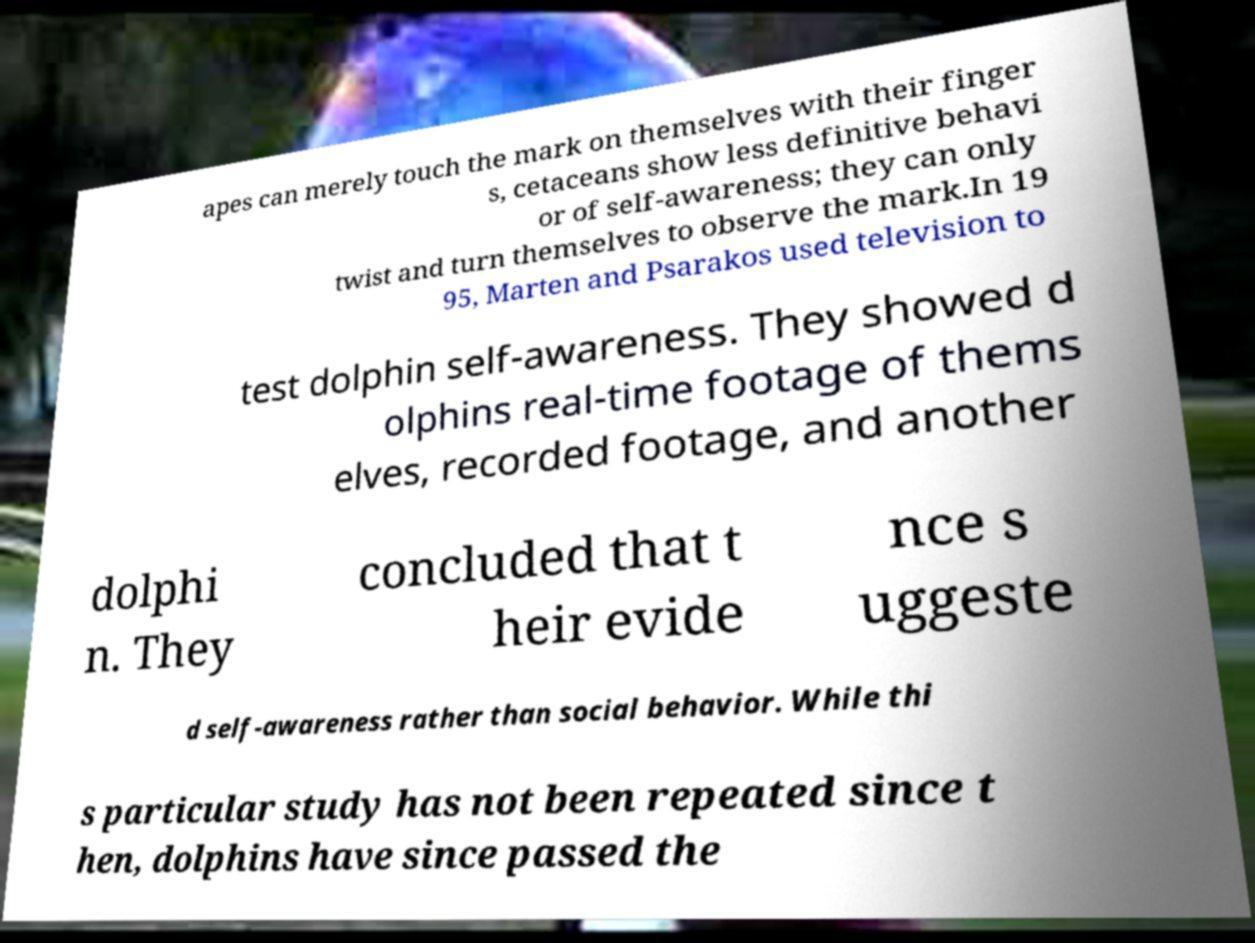Please identify and transcribe the text found in this image. apes can merely touch the mark on themselves with their finger s, cetaceans show less definitive behavi or of self-awareness; they can only twist and turn themselves to observe the mark.In 19 95, Marten and Psarakos used television to test dolphin self-awareness. They showed d olphins real-time footage of thems elves, recorded footage, and another dolphi n. They concluded that t heir evide nce s uggeste d self-awareness rather than social behavior. While thi s particular study has not been repeated since t hen, dolphins have since passed the 